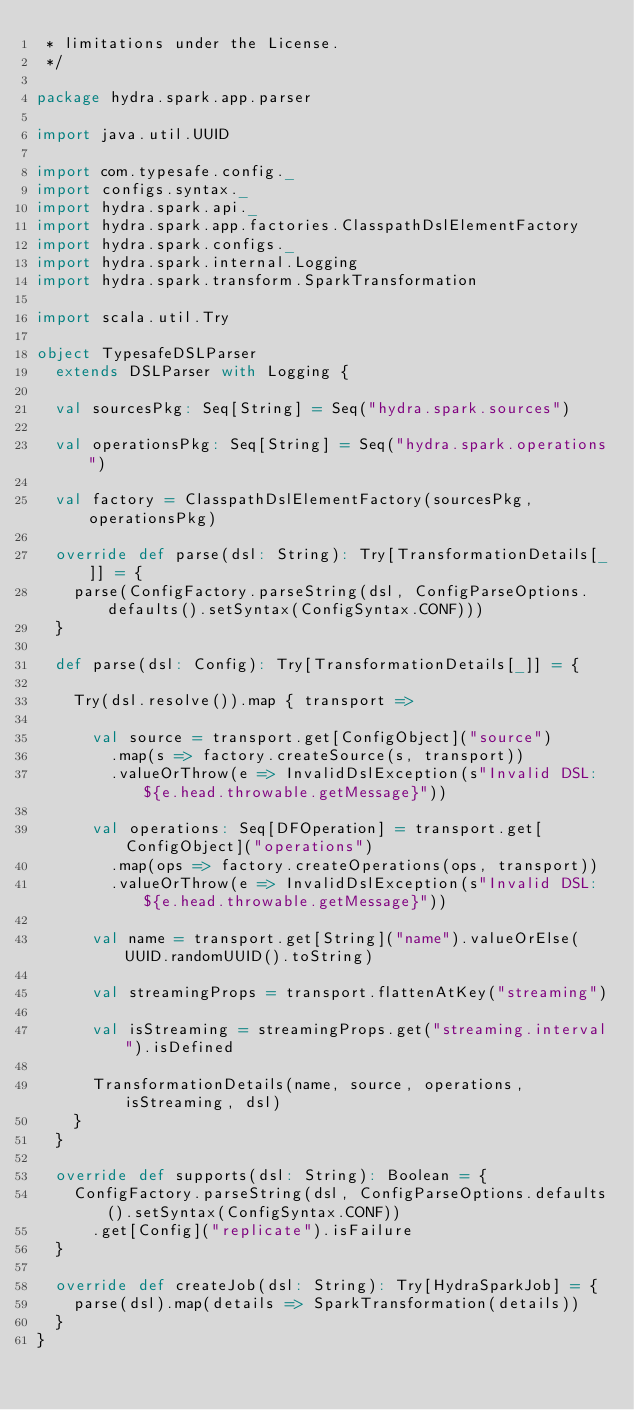<code> <loc_0><loc_0><loc_500><loc_500><_Scala_> * limitations under the License.
 */

package hydra.spark.app.parser

import java.util.UUID

import com.typesafe.config._
import configs.syntax._
import hydra.spark.api._
import hydra.spark.app.factories.ClasspathDslElementFactory
import hydra.spark.configs._
import hydra.spark.internal.Logging
import hydra.spark.transform.SparkTransformation

import scala.util.Try

object TypesafeDSLParser
  extends DSLParser with Logging {

  val sourcesPkg: Seq[String] = Seq("hydra.spark.sources")

  val operationsPkg: Seq[String] = Seq("hydra.spark.operations")

  val factory = ClasspathDslElementFactory(sourcesPkg, operationsPkg)

  override def parse(dsl: String): Try[TransformationDetails[_]] = {
    parse(ConfigFactory.parseString(dsl, ConfigParseOptions.defaults().setSyntax(ConfigSyntax.CONF)))
  }

  def parse(dsl: Config): Try[TransformationDetails[_]] = {

    Try(dsl.resolve()).map { transport =>

      val source = transport.get[ConfigObject]("source")
        .map(s => factory.createSource(s, transport))
        .valueOrThrow(e => InvalidDslException(s"Invalid DSL: ${e.head.throwable.getMessage}"))

      val operations: Seq[DFOperation] = transport.get[ConfigObject]("operations")
        .map(ops => factory.createOperations(ops, transport))
        .valueOrThrow(e => InvalidDslException(s"Invalid DSL: ${e.head.throwable.getMessage}"))

      val name = transport.get[String]("name").valueOrElse(UUID.randomUUID().toString)

      val streamingProps = transport.flattenAtKey("streaming")

      val isStreaming = streamingProps.get("streaming.interval").isDefined

      TransformationDetails(name, source, operations, isStreaming, dsl)
    }
  }

  override def supports(dsl: String): Boolean = {
    ConfigFactory.parseString(dsl, ConfigParseOptions.defaults().setSyntax(ConfigSyntax.CONF))
      .get[Config]("replicate").isFailure
  }

  override def createJob(dsl: String): Try[HydraSparkJob] = {
    parse(dsl).map(details => SparkTransformation(details))
  }
}</code> 